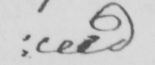What does this handwritten line say? : ceed 